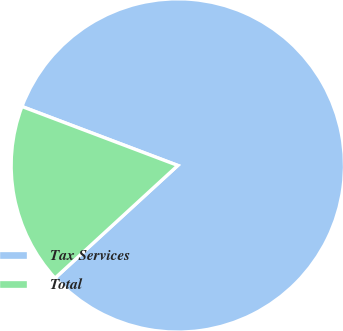Convert chart to OTSL. <chart><loc_0><loc_0><loc_500><loc_500><pie_chart><fcel>Tax Services<fcel>Total<nl><fcel>82.43%<fcel>17.57%<nl></chart> 